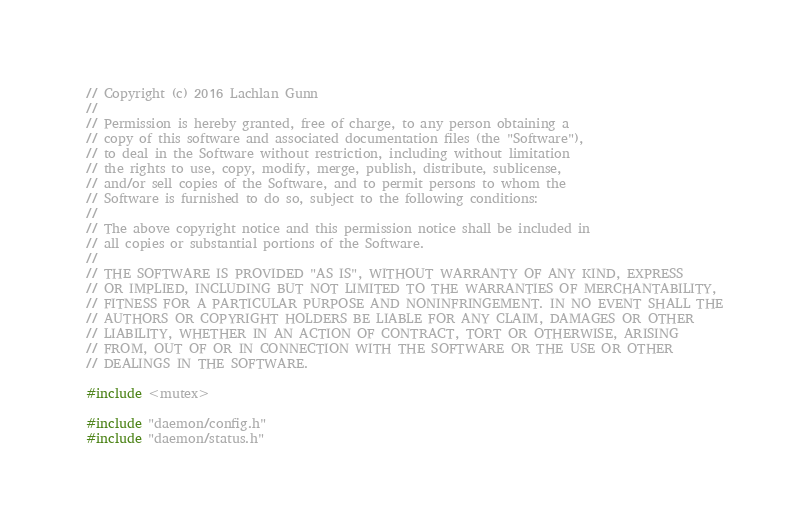Convert code to text. <code><loc_0><loc_0><loc_500><loc_500><_C++_>// Copyright (c) 2016 Lachlan Gunn
//
// Permission is hereby granted, free of charge, to any person obtaining a
// copy of this software and associated documentation files (the "Software"),
// to deal in the Software without restriction, including without limitation
// the rights to use, copy, modify, merge, publish, distribute, sublicense,
// and/or sell copies of the Software, and to permit persons to whom the
// Software is furnished to do so, subject to the following conditions:
//
// The above copyright notice and this permission notice shall be included in
// all copies or substantial portions of the Software.
//
// THE SOFTWARE IS PROVIDED "AS IS", WITHOUT WARRANTY OF ANY KIND, EXPRESS
// OR IMPLIED, INCLUDING BUT NOT LIMITED TO THE WARRANTIES OF MERCHANTABILITY,
// FITNESS FOR A PARTICULAR PURPOSE AND NONINFRINGEMENT. IN NO EVENT SHALL THE
// AUTHORS OR COPYRIGHT HOLDERS BE LIABLE FOR ANY CLAIM, DAMAGES OR OTHER
// LIABILITY, WHETHER IN AN ACTION OF CONTRACT, TORT OR OTHERWISE, ARISING
// FROM, OUT OF OR IN CONNECTION WITH THE SOFTWARE OR THE USE OR OTHER
// DEALINGS IN THE SOFTWARE.

#include <mutex>

#include "daemon/config.h"
#include "daemon/status.h"</code> 